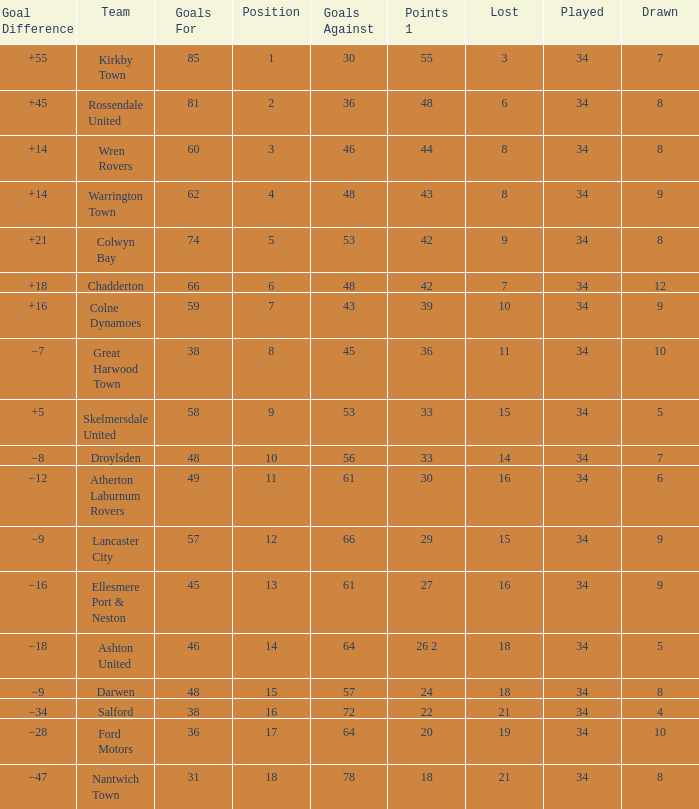What is the smallest number of goals against when 8 games were lost, and the goals for are 60? 46.0. 